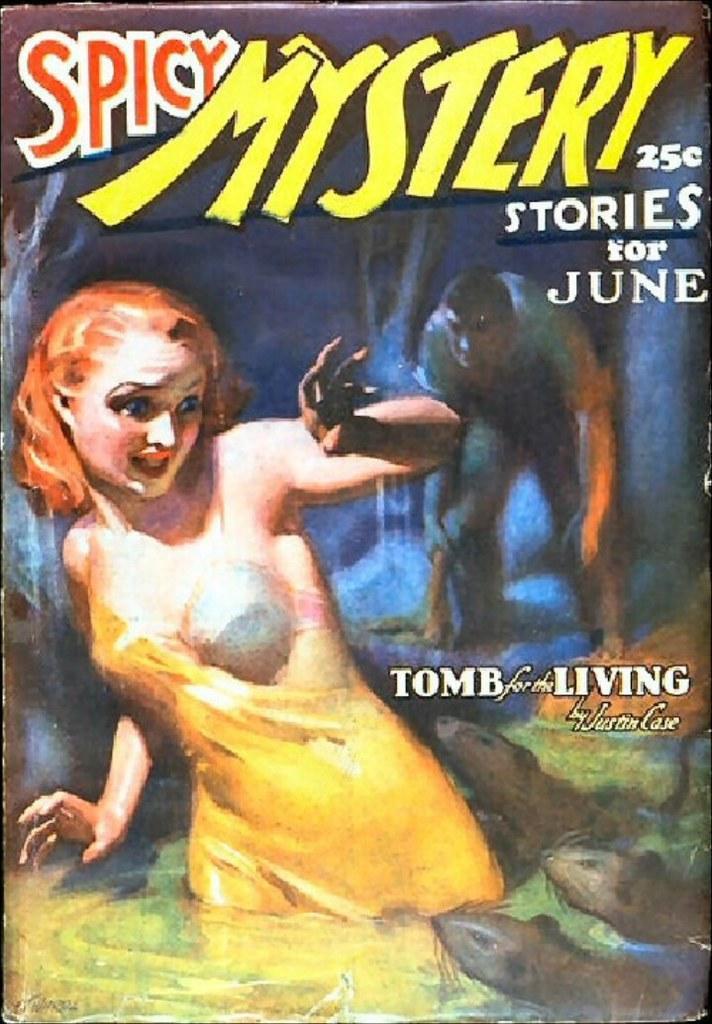Describe this image in one or two sentences. In the image we can see the poster, in the poster we can see the pictures of the people, animals and some text. 